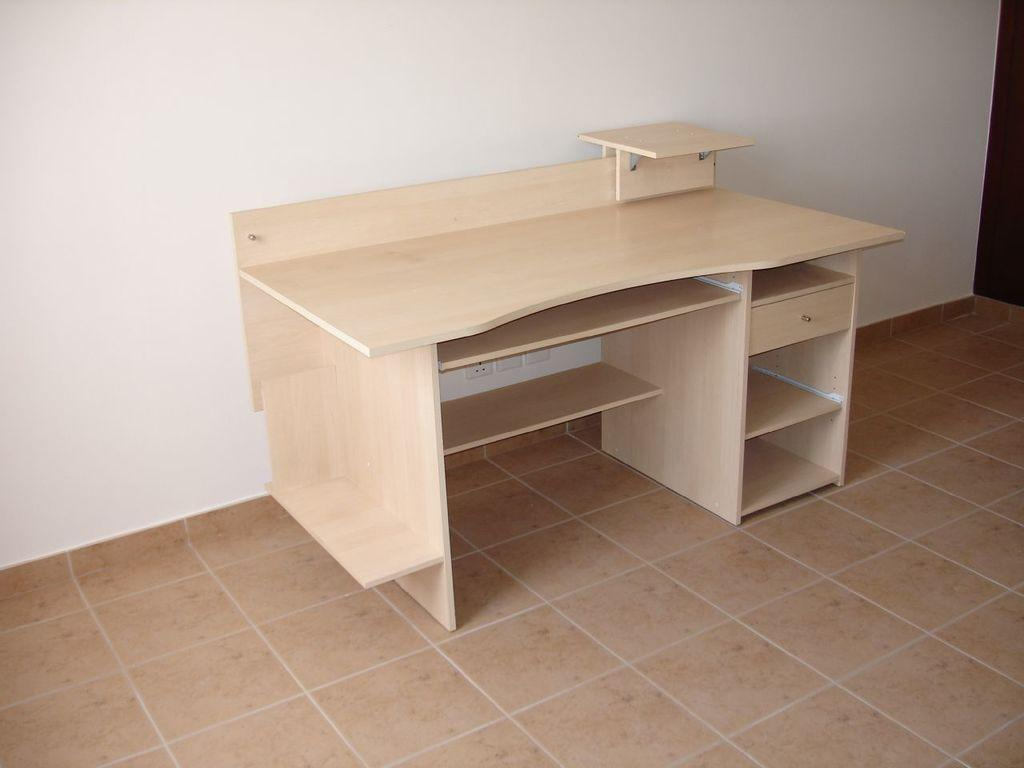What type of furniture is in the image? There is a cream-colored table in the image. What other piece of furniture can be seen on the right side of the image? There is a desk on the right side of the image. What is visible in the background of the image? There is a wall in the background of the image. What type of bone is visible on the table in the image? There is no bone present on the table in the image. What type of airplane can be seen flying in the background of the image? There is no airplane visible in the image; only a wall is present in the background. 